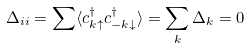Convert formula to latex. <formula><loc_0><loc_0><loc_500><loc_500>\Delta _ { i i } = \sum \langle c _ { { k } \uparrow } ^ { \dagger } c _ { - { k } \downarrow } ^ { \dagger } \rangle = \sum _ { k } \Delta _ { k } = 0</formula> 